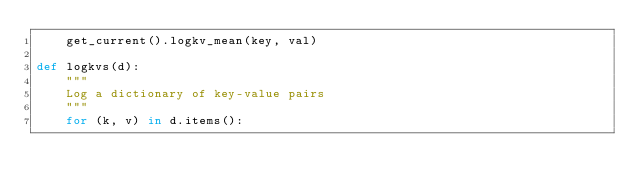Convert code to text. <code><loc_0><loc_0><loc_500><loc_500><_Python_>    get_current().logkv_mean(key, val)

def logkvs(d):
    """
    Log a dictionary of key-value pairs
    """
    for (k, v) in d.items():</code> 